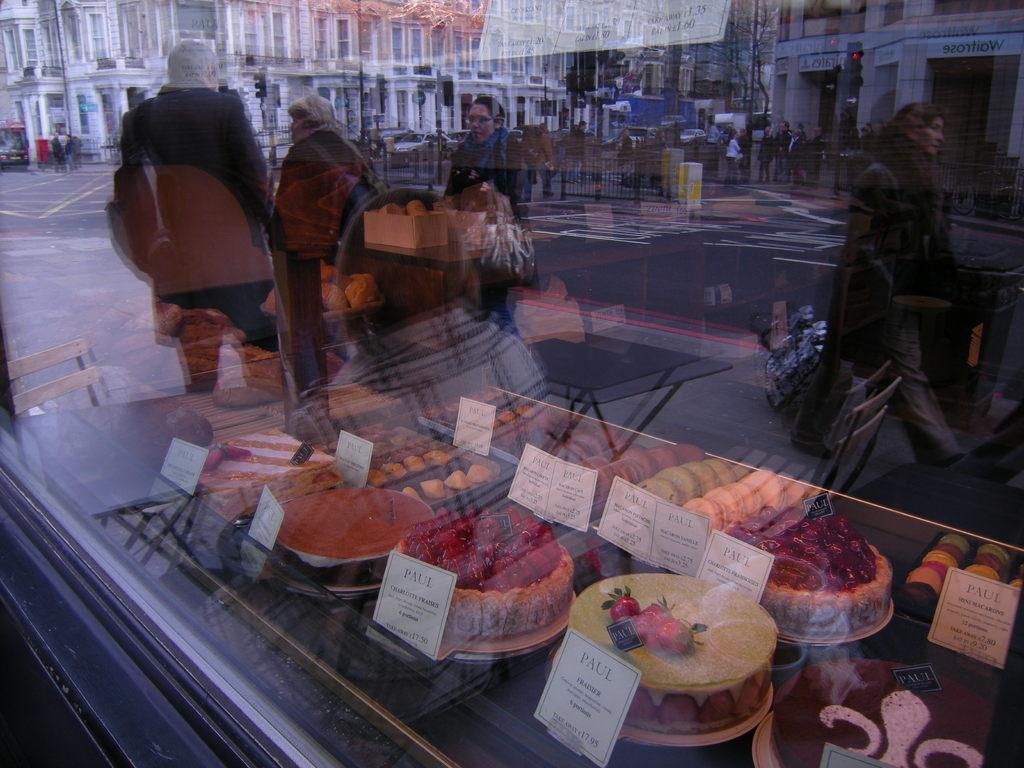In one or two sentences, can you explain what this image depicts? In this image we can see the glass windows through which we can see the people walking on the road, we can see the fence, traffic signal poles and buildings. Here we can see the reflection of cakes kept on the table and we can see the price tags. 